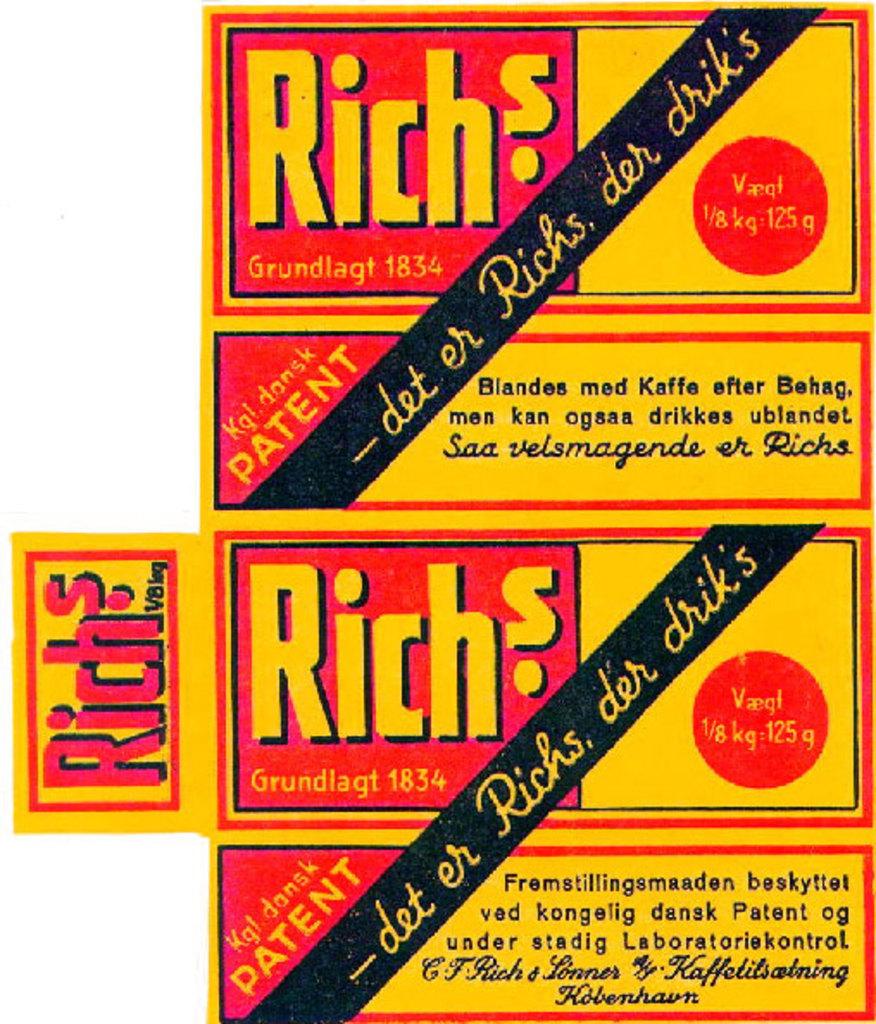What is the word that is repeated over and over?
Provide a short and direct response. Rich's. What is the weight displayed on the package?
Your answer should be very brief. 125g. 